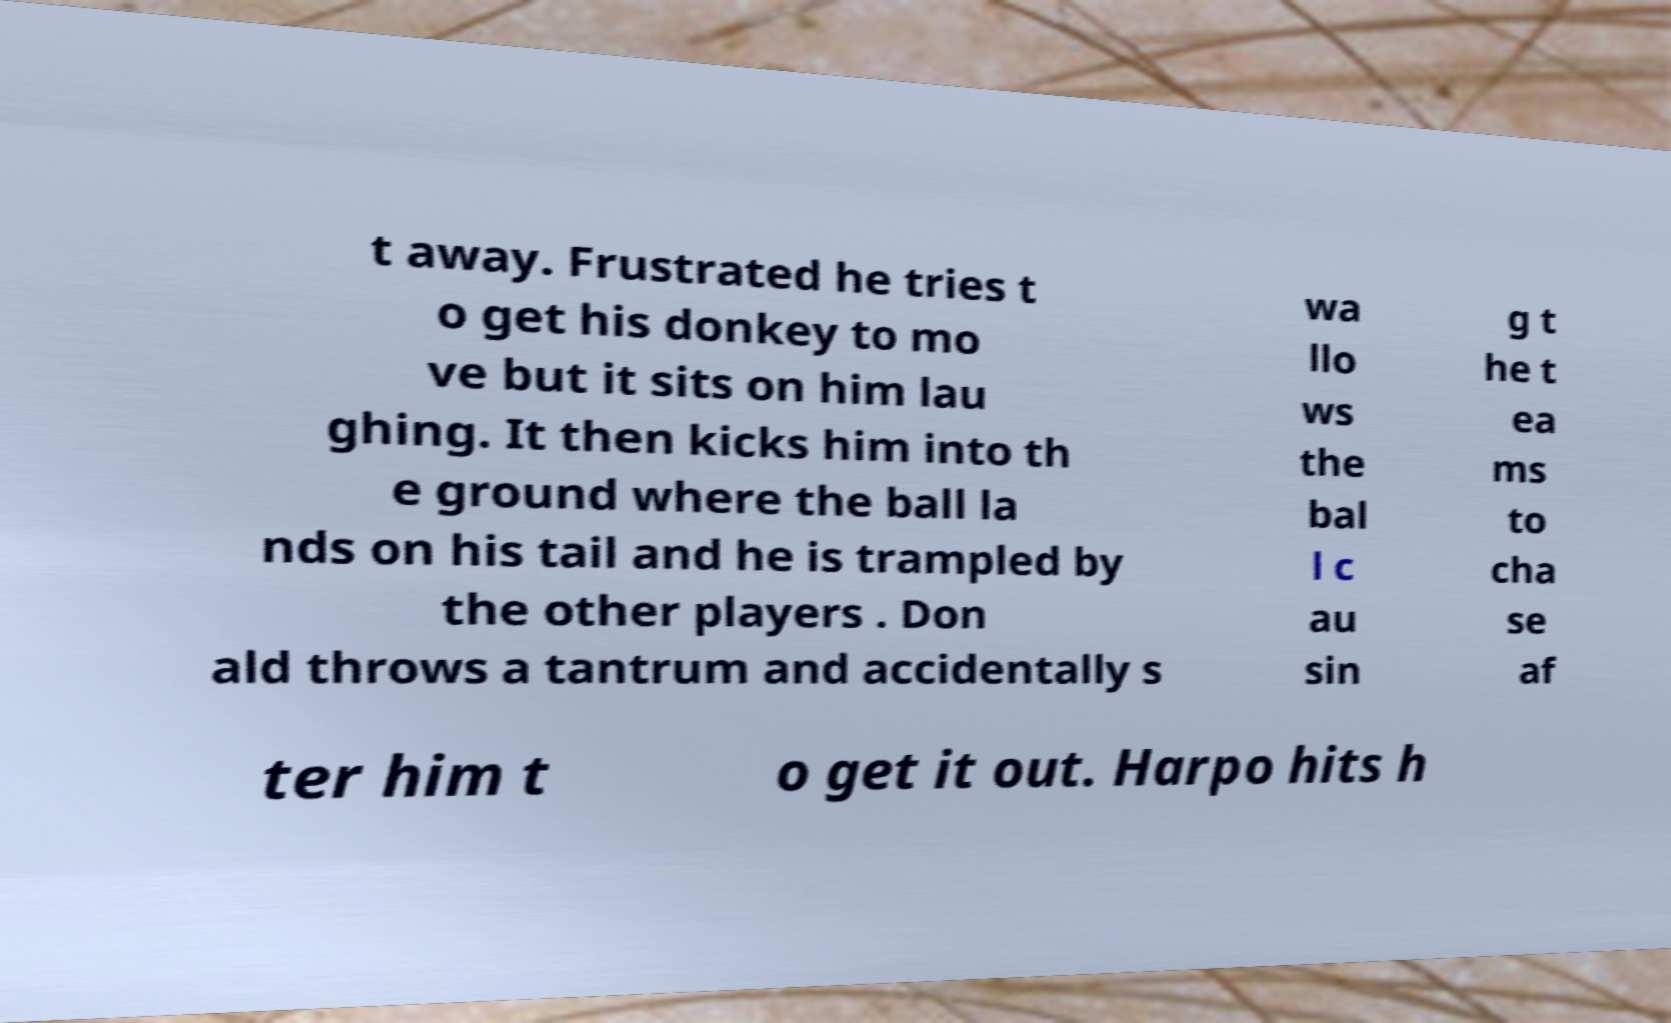Please read and relay the text visible in this image. What does it say? t away. Frustrated he tries t o get his donkey to mo ve but it sits on him lau ghing. It then kicks him into th e ground where the ball la nds on his tail and he is trampled by the other players . Don ald throws a tantrum and accidentally s wa llo ws the bal l c au sin g t he t ea ms to cha se af ter him t o get it out. Harpo hits h 